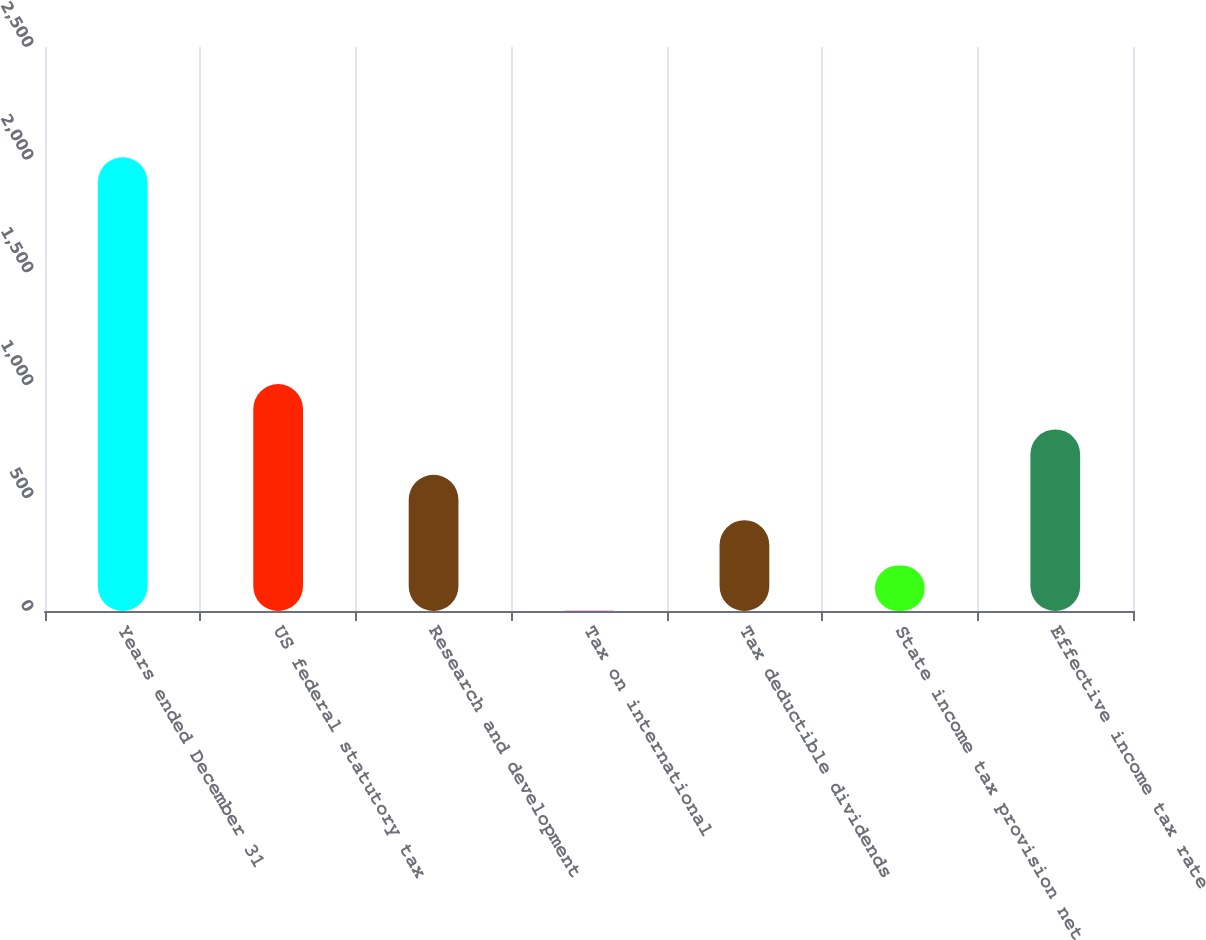Convert chart. <chart><loc_0><loc_0><loc_500><loc_500><bar_chart><fcel>Years ended December 31<fcel>US federal statutory tax<fcel>Research and development<fcel>Tax on international<fcel>Tax deductible dividends<fcel>State income tax provision net<fcel>Effective income tax rate<nl><fcel>2011<fcel>1005.8<fcel>603.72<fcel>0.6<fcel>402.68<fcel>201.64<fcel>804.76<nl></chart> 